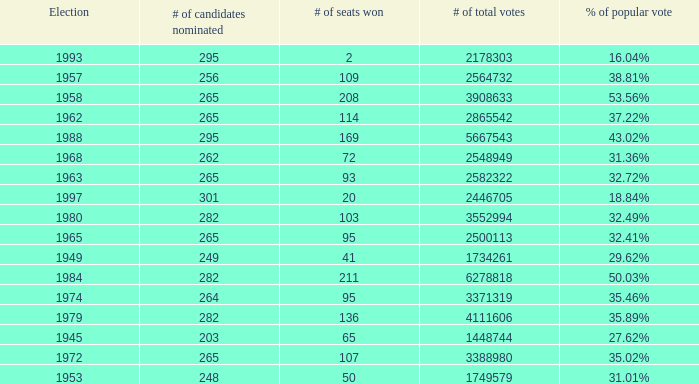How many times was the # of total votes 2582322? 1.0. 